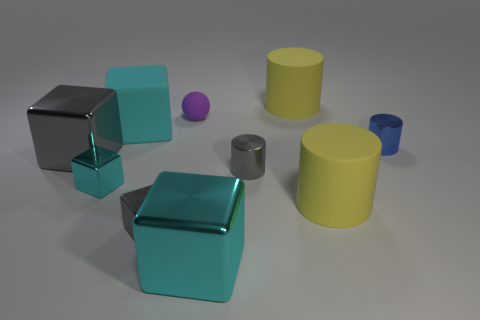Subtract all gray metal blocks. How many blocks are left? 3 Subtract all cyan balls. How many cyan blocks are left? 3 Subtract 2 blocks. How many blocks are left? 3 Subtract all gray cylinders. How many cylinders are left? 3 Subtract all spheres. How many objects are left? 9 Subtract all green blocks. Subtract all blue balls. How many blocks are left? 5 Add 8 large gray cubes. How many large gray cubes are left? 9 Add 10 tiny green matte things. How many tiny green matte things exist? 10 Subtract 0 cyan spheres. How many objects are left? 10 Subtract all large gray objects. Subtract all rubber things. How many objects are left? 5 